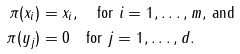<formula> <loc_0><loc_0><loc_500><loc_500>\pi ( x _ { i } ) & = x _ { i } , \quad \text {for $i=1, \dots, m,$ and} \\ \pi ( y _ { j } ) & = 0 \quad \text {for  $j=1, \dots, d.$}</formula> 